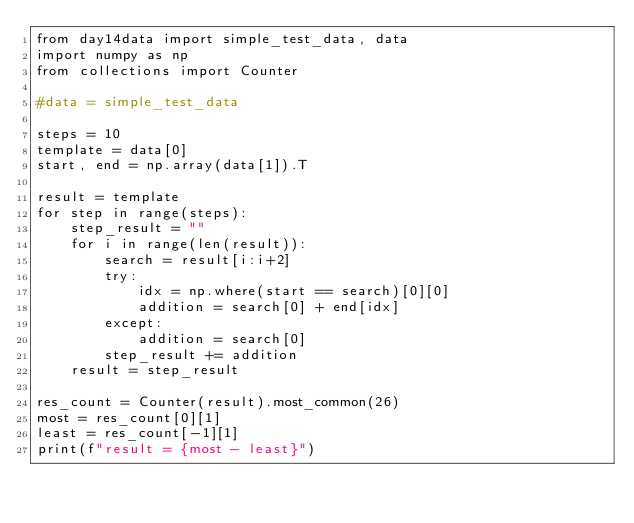Convert code to text. <code><loc_0><loc_0><loc_500><loc_500><_Python_>from day14data import simple_test_data, data
import numpy as np
from collections import Counter

#data = simple_test_data

steps = 10
template = data[0]
start, end = np.array(data[1]).T

result = template
for step in range(steps):
    step_result = ""
    for i in range(len(result)):
        search = result[i:i+2]
        try:
            idx = np.where(start == search)[0][0]
            addition = search[0] + end[idx]
        except:
            addition = search[0]
        step_result += addition
    result = step_result

res_count = Counter(result).most_common(26)
most = res_count[0][1]
least = res_count[-1][1]
print(f"result = {most - least}")</code> 